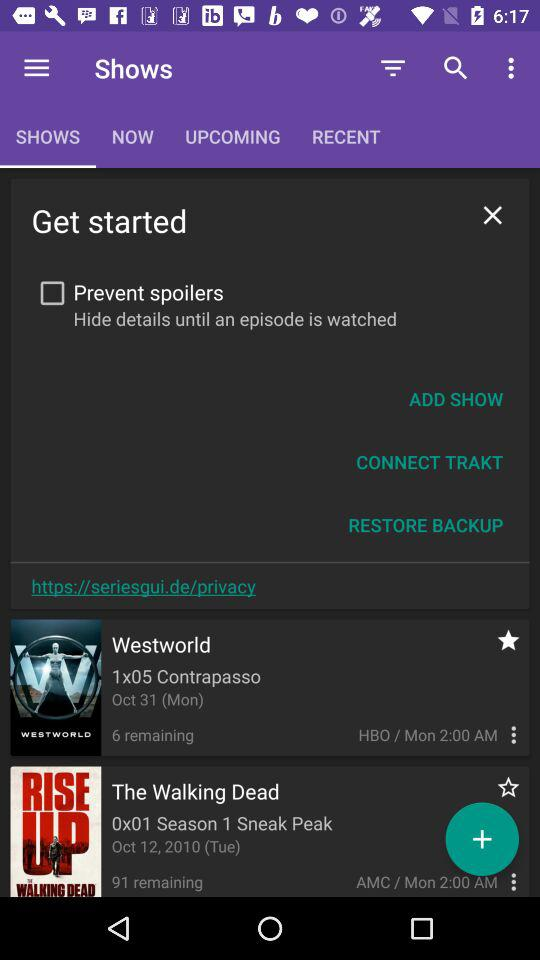What is the time for "Westworld"? The time for "Westworld" is 2:00 AM. 